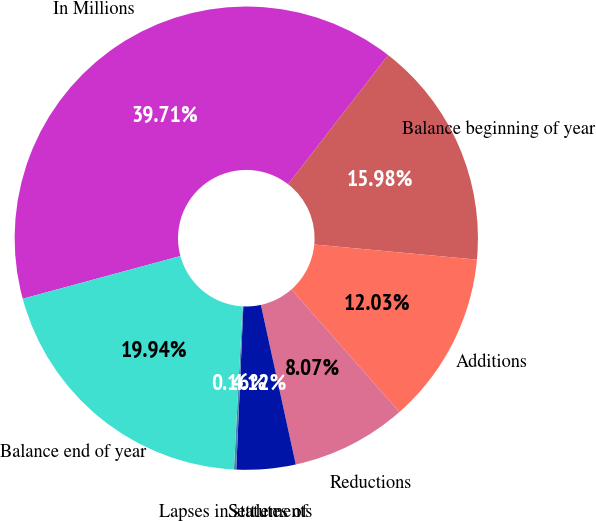Convert chart to OTSL. <chart><loc_0><loc_0><loc_500><loc_500><pie_chart><fcel>In Millions<fcel>Balance beginning of year<fcel>Additions<fcel>Reductions<fcel>Settlements<fcel>Lapses in statutes of<fcel>Balance end of year<nl><fcel>39.71%<fcel>15.98%<fcel>12.03%<fcel>8.07%<fcel>4.12%<fcel>0.16%<fcel>19.94%<nl></chart> 